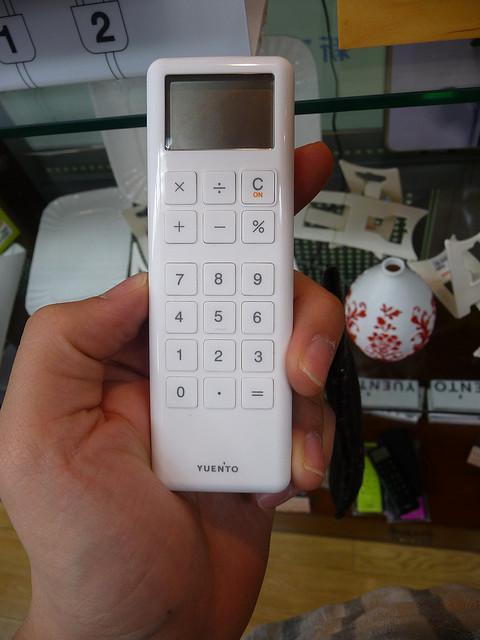How many red bird in this image?
Give a very brief answer. 0. 